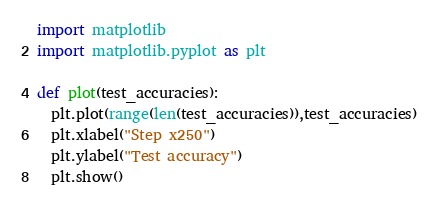Convert code to text. <code><loc_0><loc_0><loc_500><loc_500><_Python_>import matplotlib
import matplotlib.pyplot as plt

def plot(test_accuracies):
  plt.plot(range(len(test_accuracies)),test_accuracies)
  plt.xlabel("Step x250")
  plt.ylabel("Test accuracy")
  plt.show()</code> 